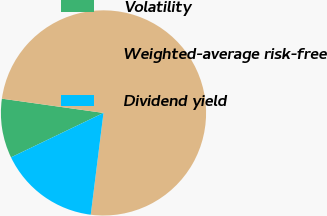<chart> <loc_0><loc_0><loc_500><loc_500><pie_chart><fcel>Volatility<fcel>Weighted-average risk-free<fcel>Dividend yield<nl><fcel>9.35%<fcel>74.77%<fcel>15.89%<nl></chart> 